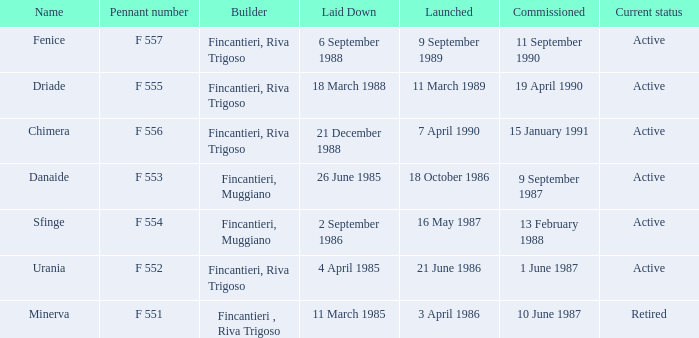Which launch date involved the Driade? 11 March 1989. 